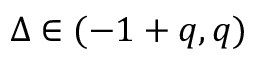<formula> <loc_0><loc_0><loc_500><loc_500>\Delta \in ( - 1 + q , q )</formula> 